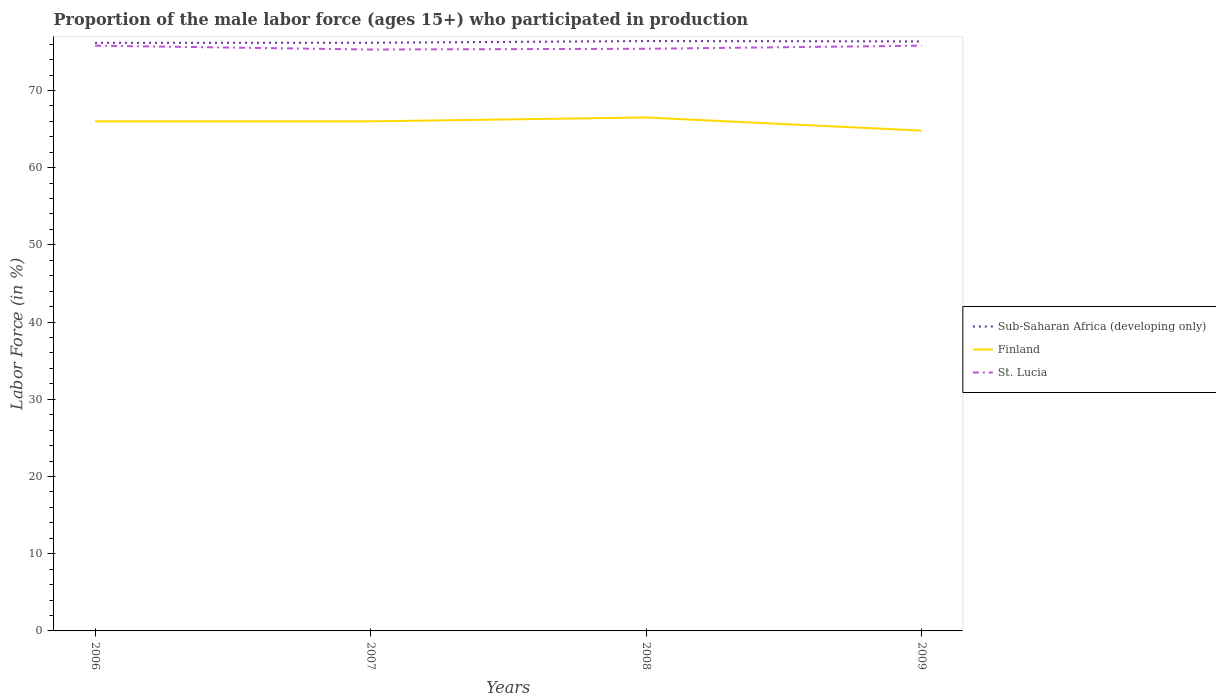How many different coloured lines are there?
Provide a succinct answer. 3. Is the number of lines equal to the number of legend labels?
Provide a succinct answer. Yes. Across all years, what is the maximum proportion of the male labor force who participated in production in St. Lucia?
Your answer should be very brief. 75.3. What is the total proportion of the male labor force who participated in production in Sub-Saharan Africa (developing only) in the graph?
Make the answer very short. -0.24. What is the difference between the highest and the second highest proportion of the male labor force who participated in production in Sub-Saharan Africa (developing only)?
Offer a terse response. 0.24. How many years are there in the graph?
Your answer should be compact. 4. What is the difference between two consecutive major ticks on the Y-axis?
Ensure brevity in your answer.  10. Does the graph contain grids?
Your answer should be compact. No. Where does the legend appear in the graph?
Offer a terse response. Center right. What is the title of the graph?
Offer a terse response. Proportion of the male labor force (ages 15+) who participated in production. Does "Azerbaijan" appear as one of the legend labels in the graph?
Your answer should be compact. No. What is the label or title of the Y-axis?
Your answer should be compact. Labor Force (in %). What is the Labor Force (in %) of Sub-Saharan Africa (developing only) in 2006?
Provide a short and direct response. 76.16. What is the Labor Force (in %) in St. Lucia in 2006?
Your answer should be compact. 75.8. What is the Labor Force (in %) of Sub-Saharan Africa (developing only) in 2007?
Ensure brevity in your answer.  76.18. What is the Labor Force (in %) in Finland in 2007?
Provide a succinct answer. 66. What is the Labor Force (in %) of St. Lucia in 2007?
Offer a terse response. 75.3. What is the Labor Force (in %) in Sub-Saharan Africa (developing only) in 2008?
Give a very brief answer. 76.4. What is the Labor Force (in %) in Finland in 2008?
Make the answer very short. 66.5. What is the Labor Force (in %) of St. Lucia in 2008?
Provide a short and direct response. 75.4. What is the Labor Force (in %) of Sub-Saharan Africa (developing only) in 2009?
Ensure brevity in your answer.  76.35. What is the Labor Force (in %) of Finland in 2009?
Your answer should be compact. 64.8. What is the Labor Force (in %) in St. Lucia in 2009?
Give a very brief answer. 75.8. Across all years, what is the maximum Labor Force (in %) of Sub-Saharan Africa (developing only)?
Give a very brief answer. 76.4. Across all years, what is the maximum Labor Force (in %) in Finland?
Make the answer very short. 66.5. Across all years, what is the maximum Labor Force (in %) in St. Lucia?
Make the answer very short. 75.8. Across all years, what is the minimum Labor Force (in %) of Sub-Saharan Africa (developing only)?
Offer a very short reply. 76.16. Across all years, what is the minimum Labor Force (in %) in Finland?
Make the answer very short. 64.8. Across all years, what is the minimum Labor Force (in %) of St. Lucia?
Offer a terse response. 75.3. What is the total Labor Force (in %) in Sub-Saharan Africa (developing only) in the graph?
Your response must be concise. 305.09. What is the total Labor Force (in %) of Finland in the graph?
Your answer should be very brief. 263.3. What is the total Labor Force (in %) in St. Lucia in the graph?
Your answer should be very brief. 302.3. What is the difference between the Labor Force (in %) in Sub-Saharan Africa (developing only) in 2006 and that in 2007?
Provide a short and direct response. -0.02. What is the difference between the Labor Force (in %) in Finland in 2006 and that in 2007?
Ensure brevity in your answer.  0. What is the difference between the Labor Force (in %) of St. Lucia in 2006 and that in 2007?
Offer a very short reply. 0.5. What is the difference between the Labor Force (in %) in Sub-Saharan Africa (developing only) in 2006 and that in 2008?
Keep it short and to the point. -0.24. What is the difference between the Labor Force (in %) in Sub-Saharan Africa (developing only) in 2006 and that in 2009?
Ensure brevity in your answer.  -0.19. What is the difference between the Labor Force (in %) of Finland in 2006 and that in 2009?
Offer a terse response. 1.2. What is the difference between the Labor Force (in %) of St. Lucia in 2006 and that in 2009?
Provide a succinct answer. 0. What is the difference between the Labor Force (in %) of Sub-Saharan Africa (developing only) in 2007 and that in 2008?
Keep it short and to the point. -0.22. What is the difference between the Labor Force (in %) of Finland in 2007 and that in 2008?
Offer a terse response. -0.5. What is the difference between the Labor Force (in %) in St. Lucia in 2007 and that in 2008?
Offer a very short reply. -0.1. What is the difference between the Labor Force (in %) in Sub-Saharan Africa (developing only) in 2007 and that in 2009?
Offer a very short reply. -0.18. What is the difference between the Labor Force (in %) of Finland in 2007 and that in 2009?
Provide a short and direct response. 1.2. What is the difference between the Labor Force (in %) of Sub-Saharan Africa (developing only) in 2008 and that in 2009?
Your answer should be compact. 0.04. What is the difference between the Labor Force (in %) of Sub-Saharan Africa (developing only) in 2006 and the Labor Force (in %) of Finland in 2007?
Offer a very short reply. 10.16. What is the difference between the Labor Force (in %) of Sub-Saharan Africa (developing only) in 2006 and the Labor Force (in %) of St. Lucia in 2007?
Provide a short and direct response. 0.86. What is the difference between the Labor Force (in %) of Finland in 2006 and the Labor Force (in %) of St. Lucia in 2007?
Offer a terse response. -9.3. What is the difference between the Labor Force (in %) of Sub-Saharan Africa (developing only) in 2006 and the Labor Force (in %) of Finland in 2008?
Offer a terse response. 9.66. What is the difference between the Labor Force (in %) in Sub-Saharan Africa (developing only) in 2006 and the Labor Force (in %) in St. Lucia in 2008?
Offer a very short reply. 0.76. What is the difference between the Labor Force (in %) in Finland in 2006 and the Labor Force (in %) in St. Lucia in 2008?
Provide a succinct answer. -9.4. What is the difference between the Labor Force (in %) in Sub-Saharan Africa (developing only) in 2006 and the Labor Force (in %) in Finland in 2009?
Provide a succinct answer. 11.36. What is the difference between the Labor Force (in %) in Sub-Saharan Africa (developing only) in 2006 and the Labor Force (in %) in St. Lucia in 2009?
Ensure brevity in your answer.  0.36. What is the difference between the Labor Force (in %) in Finland in 2006 and the Labor Force (in %) in St. Lucia in 2009?
Give a very brief answer. -9.8. What is the difference between the Labor Force (in %) in Sub-Saharan Africa (developing only) in 2007 and the Labor Force (in %) in Finland in 2008?
Your answer should be very brief. 9.68. What is the difference between the Labor Force (in %) in Sub-Saharan Africa (developing only) in 2007 and the Labor Force (in %) in St. Lucia in 2008?
Provide a succinct answer. 0.78. What is the difference between the Labor Force (in %) in Finland in 2007 and the Labor Force (in %) in St. Lucia in 2008?
Offer a terse response. -9.4. What is the difference between the Labor Force (in %) of Sub-Saharan Africa (developing only) in 2007 and the Labor Force (in %) of Finland in 2009?
Provide a short and direct response. 11.38. What is the difference between the Labor Force (in %) in Sub-Saharan Africa (developing only) in 2007 and the Labor Force (in %) in St. Lucia in 2009?
Give a very brief answer. 0.38. What is the difference between the Labor Force (in %) in Sub-Saharan Africa (developing only) in 2008 and the Labor Force (in %) in Finland in 2009?
Ensure brevity in your answer.  11.6. What is the difference between the Labor Force (in %) in Sub-Saharan Africa (developing only) in 2008 and the Labor Force (in %) in St. Lucia in 2009?
Give a very brief answer. 0.6. What is the difference between the Labor Force (in %) in Finland in 2008 and the Labor Force (in %) in St. Lucia in 2009?
Give a very brief answer. -9.3. What is the average Labor Force (in %) of Sub-Saharan Africa (developing only) per year?
Ensure brevity in your answer.  76.27. What is the average Labor Force (in %) of Finland per year?
Keep it short and to the point. 65.83. What is the average Labor Force (in %) in St. Lucia per year?
Keep it short and to the point. 75.58. In the year 2006, what is the difference between the Labor Force (in %) in Sub-Saharan Africa (developing only) and Labor Force (in %) in Finland?
Provide a short and direct response. 10.16. In the year 2006, what is the difference between the Labor Force (in %) in Sub-Saharan Africa (developing only) and Labor Force (in %) in St. Lucia?
Make the answer very short. 0.36. In the year 2007, what is the difference between the Labor Force (in %) in Sub-Saharan Africa (developing only) and Labor Force (in %) in Finland?
Offer a very short reply. 10.18. In the year 2007, what is the difference between the Labor Force (in %) in Sub-Saharan Africa (developing only) and Labor Force (in %) in St. Lucia?
Ensure brevity in your answer.  0.88. In the year 2008, what is the difference between the Labor Force (in %) in Sub-Saharan Africa (developing only) and Labor Force (in %) in Finland?
Your response must be concise. 9.9. In the year 2008, what is the difference between the Labor Force (in %) in Finland and Labor Force (in %) in St. Lucia?
Make the answer very short. -8.9. In the year 2009, what is the difference between the Labor Force (in %) in Sub-Saharan Africa (developing only) and Labor Force (in %) in Finland?
Keep it short and to the point. 11.55. In the year 2009, what is the difference between the Labor Force (in %) of Sub-Saharan Africa (developing only) and Labor Force (in %) of St. Lucia?
Give a very brief answer. 0.55. What is the ratio of the Labor Force (in %) of St. Lucia in 2006 to that in 2007?
Keep it short and to the point. 1.01. What is the ratio of the Labor Force (in %) of Sub-Saharan Africa (developing only) in 2006 to that in 2008?
Offer a very short reply. 1. What is the ratio of the Labor Force (in %) in St. Lucia in 2006 to that in 2008?
Your answer should be compact. 1.01. What is the ratio of the Labor Force (in %) of Finland in 2006 to that in 2009?
Provide a succinct answer. 1.02. What is the ratio of the Labor Force (in %) in St. Lucia in 2006 to that in 2009?
Offer a terse response. 1. What is the ratio of the Labor Force (in %) of St. Lucia in 2007 to that in 2008?
Your answer should be compact. 1. What is the ratio of the Labor Force (in %) in Finland in 2007 to that in 2009?
Your answer should be compact. 1.02. What is the ratio of the Labor Force (in %) in St. Lucia in 2007 to that in 2009?
Your answer should be compact. 0.99. What is the ratio of the Labor Force (in %) in Sub-Saharan Africa (developing only) in 2008 to that in 2009?
Give a very brief answer. 1. What is the ratio of the Labor Force (in %) in Finland in 2008 to that in 2009?
Ensure brevity in your answer.  1.03. What is the difference between the highest and the second highest Labor Force (in %) of Sub-Saharan Africa (developing only)?
Your answer should be very brief. 0.04. What is the difference between the highest and the lowest Labor Force (in %) of Sub-Saharan Africa (developing only)?
Provide a succinct answer. 0.24. What is the difference between the highest and the lowest Labor Force (in %) in St. Lucia?
Your response must be concise. 0.5. 